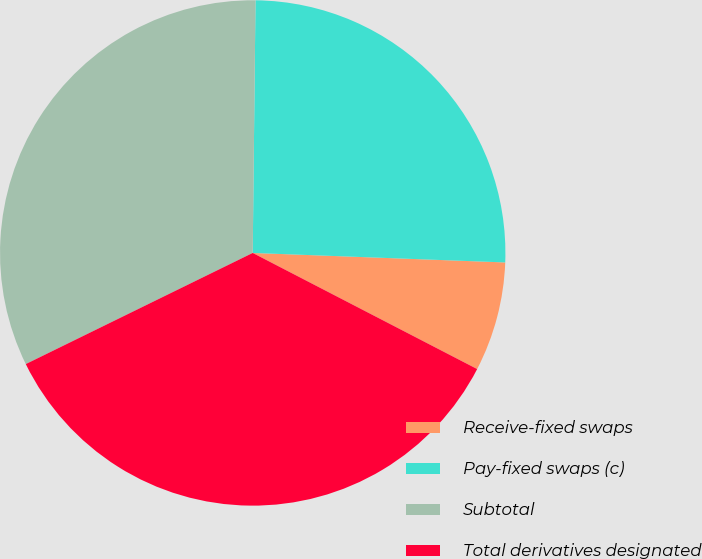Convert chart to OTSL. <chart><loc_0><loc_0><loc_500><loc_500><pie_chart><fcel>Receive-fixed swaps<fcel>Pay-fixed swaps (c)<fcel>Subtotal<fcel>Total derivatives designated<nl><fcel>7.0%<fcel>25.42%<fcel>32.42%<fcel>35.15%<nl></chart> 